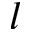Convert formula to latex. <formula><loc_0><loc_0><loc_500><loc_500>l</formula> 